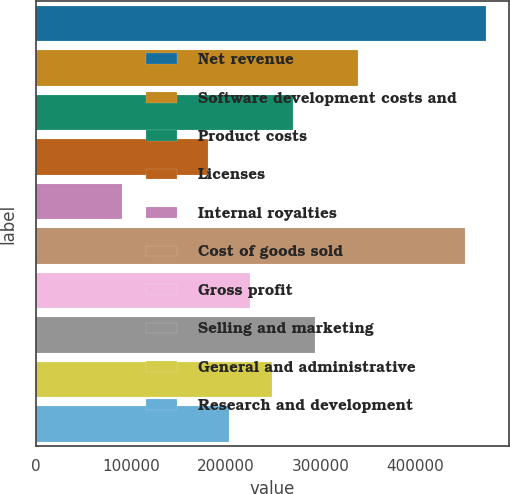Convert chart to OTSL. <chart><loc_0><loc_0><loc_500><loc_500><bar_chart><fcel>Net revenue<fcel>Software development costs and<fcel>Product costs<fcel>Licenses<fcel>Internal royalties<fcel>Cost of goods sold<fcel>Gross profit<fcel>Selling and marketing<fcel>General and administrative<fcel>Research and development<nl><fcel>474890<fcel>339208<fcel>271367<fcel>180911<fcel>90456.4<fcel>452277<fcel>226139<fcel>293980<fcel>248753<fcel>203525<nl></chart> 